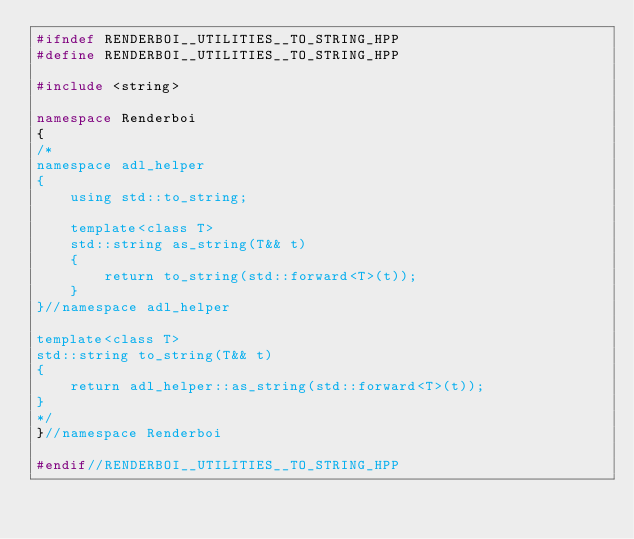Convert code to text. <code><loc_0><loc_0><loc_500><loc_500><_C++_>#ifndef RENDERBOI__UTILITIES__TO_STRING_HPP
#define RENDERBOI__UTILITIES__TO_STRING_HPP

#include <string>

namespace Renderboi
{
/*
namespace adl_helper
{
    using std::to_string;

    template<class T>
    std::string as_string(T&& t)
    {
        return to_string(std::forward<T>(t));
    }
}//namespace adl_helper

template<class T>
std::string to_string(T&& t)
{
    return adl_helper::as_string(std::forward<T>(t));
}
*/
}//namespace Renderboi

#endif//RENDERBOI__UTILITIES__TO_STRING_HPP</code> 